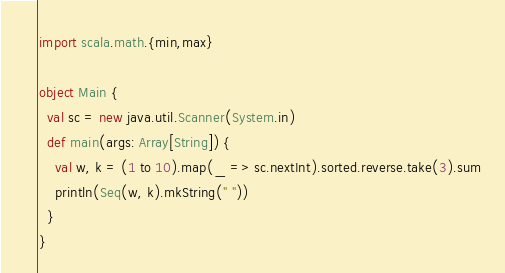<code> <loc_0><loc_0><loc_500><loc_500><_Scala_>import scala.math.{min,max}

object Main {
  val sc = new java.util.Scanner(System.in)
  def main(args: Array[String]) {
    val w, k = (1 to 10).map(_ => sc.nextInt).sorted.reverse.take(3).sum
    println(Seq(w, k).mkString(" ")) 
  }
}</code> 